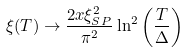<formula> <loc_0><loc_0><loc_500><loc_500>\xi ( T ) \to \frac { 2 x \xi _ { S P } ^ { 2 } } { \pi ^ { 2 } } \ln ^ { 2 } \left ( \frac { T } { \Delta } \right )</formula> 